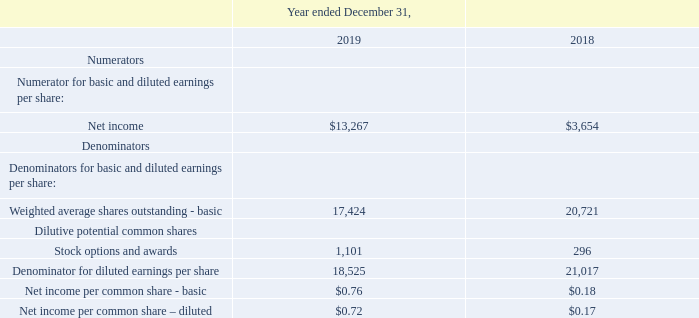Earnings per share for the periods indicated were computed as follows (in thousands except per share amounts):
Our weighted average shares outstanding has decreased due to the repurchase of our outstanding common stock through a modified Dutch auction tender offer (the “Tender Offer”) and the stock repurchase program announced on October 29, 2018.
11.     Earnings Per Share
Why did the company's weighted average shares outstanding decrease? Due to the repurchase of our outstanding common stock through a modified dutch auction tender offer (the “tender offer”) and the stock repurchase program announced on october 29, 2018. What is the basic net income per common share in 2019? $0.76. What is the diluted net income per common share in 2018? $0.17. How did the company's basic weighted average shares outstanding change from 2018 to 2019?
Answer scale should be: percent. (17,424-20,721)/20,721
Answer: -15.91. How did the company's Denominator for diluted earnings per share change from 2018 to 2019?
Answer scale should be: percent. (18,525 - 21,017)/21,017
Answer: -11.86. How much more stock options and awards did the company give out in 2019 compared to 2018?
Answer scale should be: thousand. 1,101-296
Answer: 805. 